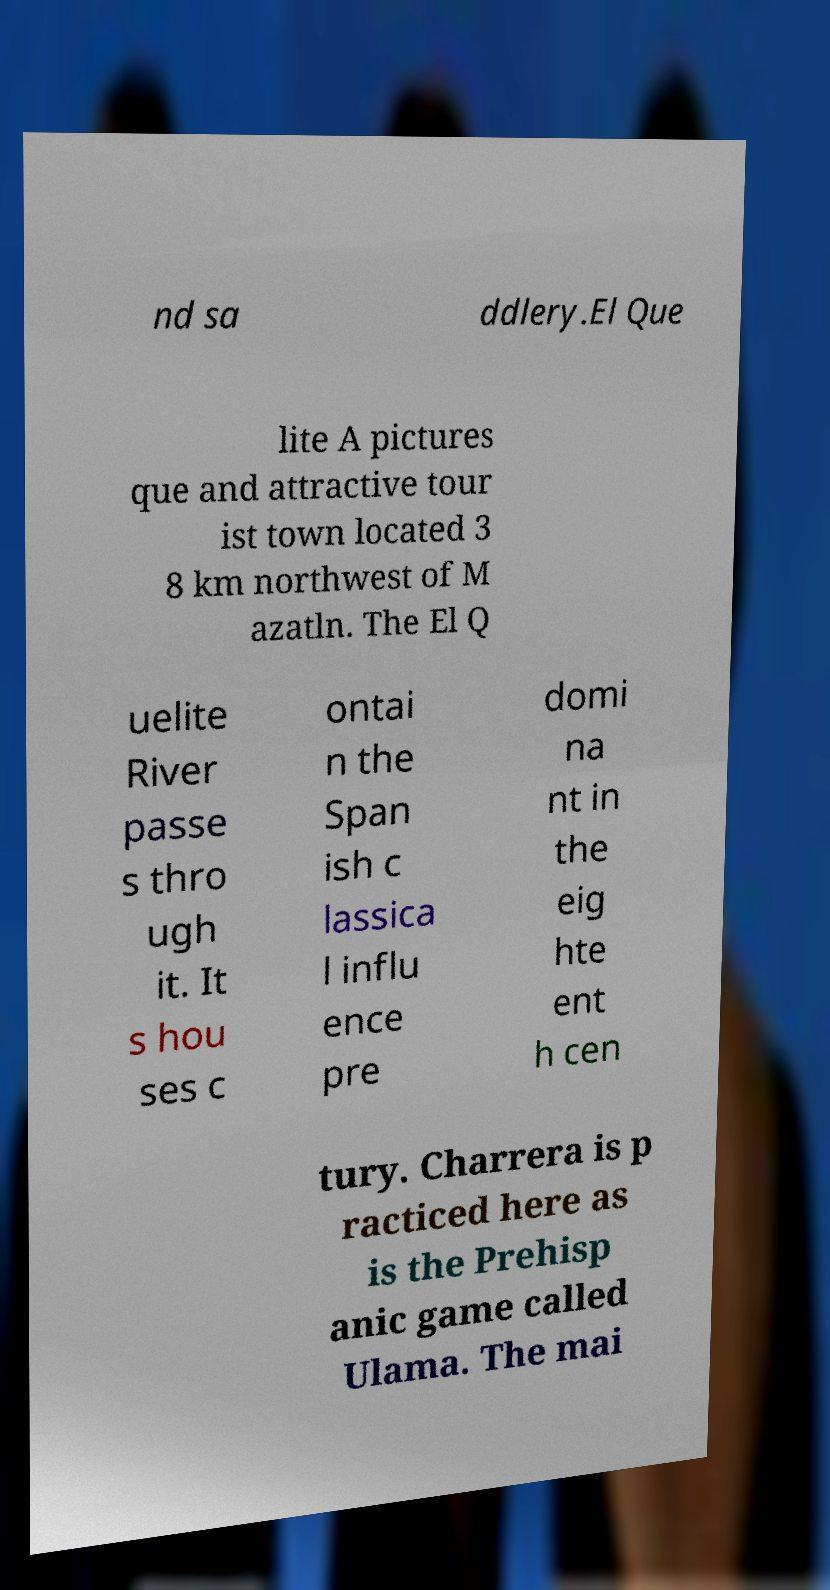For documentation purposes, I need the text within this image transcribed. Could you provide that? nd sa ddlery.El Que lite A pictures que and attractive tour ist town located 3 8 km northwest of M azatln. The El Q uelite River passe s thro ugh it. It s hou ses c ontai n the Span ish c lassica l influ ence pre domi na nt in the eig hte ent h cen tury. Charrera is p racticed here as is the Prehisp anic game called Ulama. The mai 